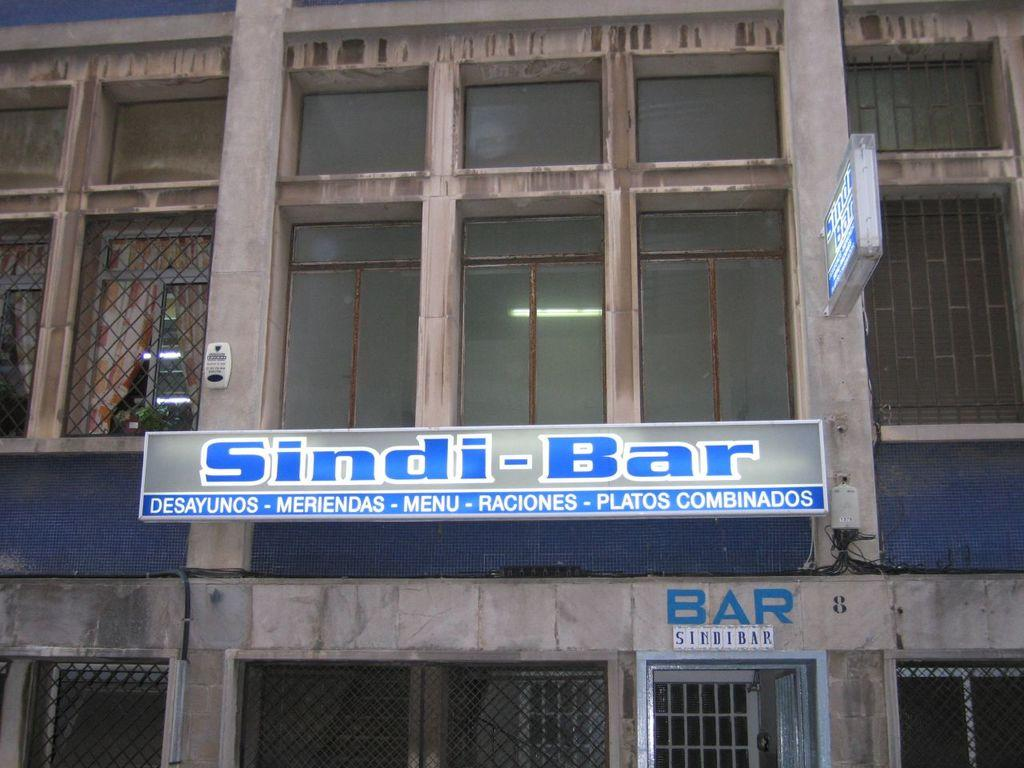What type of structure is present in the image? There is a building in the image. What features can be seen on the building? The building has windows and doors. How many beds are visible in the image? There are no beds present in the image; it features a building with windows and doors. What type of space exploration is depicted in the image? There is no space exploration depicted in the image; it features a building with windows and doors. 